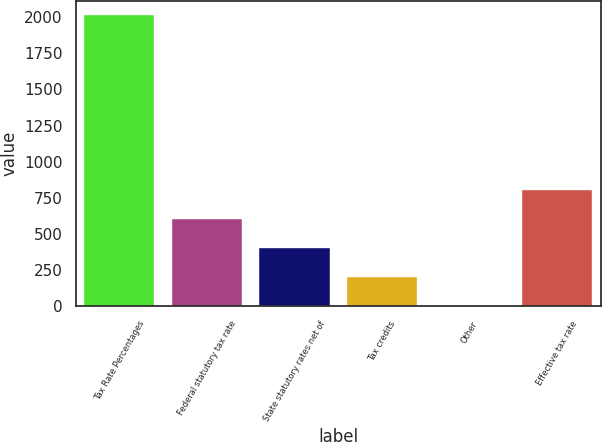Convert chart. <chart><loc_0><loc_0><loc_500><loc_500><bar_chart><fcel>Tax Rate Percentages<fcel>Federal statutory tax rate<fcel>State statutory rates net of<fcel>Tax credits<fcel>Other<fcel>Effective tax rate<nl><fcel>2015<fcel>604.57<fcel>403.08<fcel>201.59<fcel>0.1<fcel>806.06<nl></chart> 